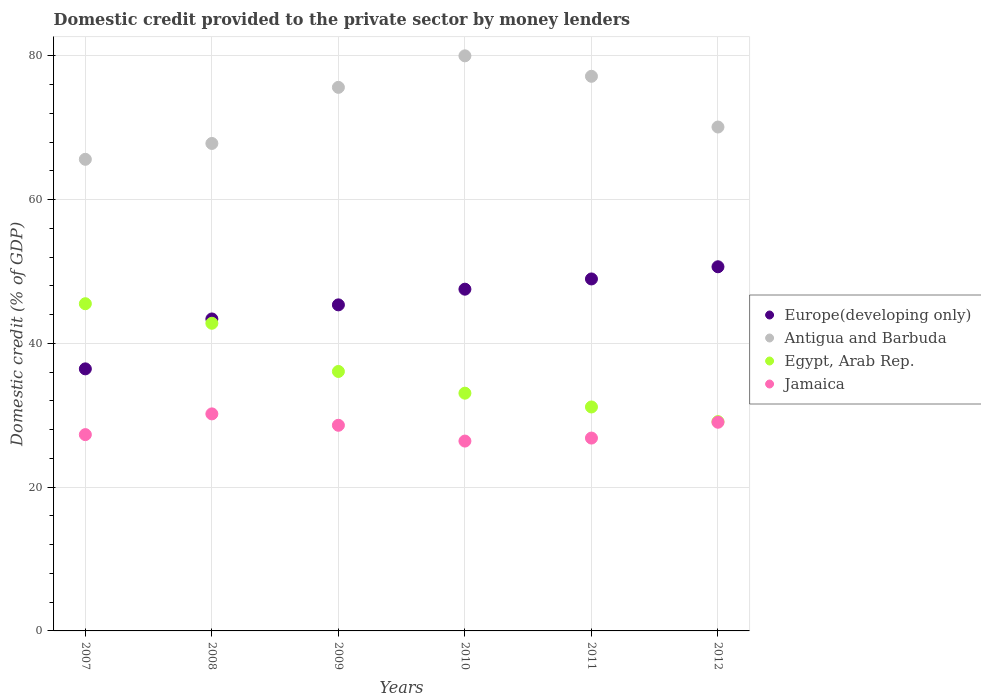How many different coloured dotlines are there?
Your answer should be very brief. 4. What is the domestic credit provided to the private sector by money lenders in Antigua and Barbuda in 2010?
Keep it short and to the point. 80. Across all years, what is the maximum domestic credit provided to the private sector by money lenders in Antigua and Barbuda?
Your response must be concise. 80. Across all years, what is the minimum domestic credit provided to the private sector by money lenders in Egypt, Arab Rep.?
Your answer should be very brief. 29.11. In which year was the domestic credit provided to the private sector by money lenders in Egypt, Arab Rep. minimum?
Your answer should be very brief. 2012. What is the total domestic credit provided to the private sector by money lenders in Europe(developing only) in the graph?
Your answer should be very brief. 272.36. What is the difference between the domestic credit provided to the private sector by money lenders in Europe(developing only) in 2009 and that in 2010?
Make the answer very short. -2.18. What is the difference between the domestic credit provided to the private sector by money lenders in Jamaica in 2012 and the domestic credit provided to the private sector by money lenders in Egypt, Arab Rep. in 2008?
Your answer should be very brief. -13.77. What is the average domestic credit provided to the private sector by money lenders in Egypt, Arab Rep. per year?
Provide a short and direct response. 36.29. In the year 2009, what is the difference between the domestic credit provided to the private sector by money lenders in Jamaica and domestic credit provided to the private sector by money lenders in Antigua and Barbuda?
Give a very brief answer. -47.01. In how many years, is the domestic credit provided to the private sector by money lenders in Antigua and Barbuda greater than 52 %?
Your answer should be very brief. 6. What is the ratio of the domestic credit provided to the private sector by money lenders in Europe(developing only) in 2009 to that in 2011?
Provide a short and direct response. 0.93. What is the difference between the highest and the second highest domestic credit provided to the private sector by money lenders in Europe(developing only)?
Your answer should be compact. 1.69. What is the difference between the highest and the lowest domestic credit provided to the private sector by money lenders in Egypt, Arab Rep.?
Keep it short and to the point. 16.4. Is the sum of the domestic credit provided to the private sector by money lenders in Europe(developing only) in 2010 and 2012 greater than the maximum domestic credit provided to the private sector by money lenders in Jamaica across all years?
Make the answer very short. Yes. Is it the case that in every year, the sum of the domestic credit provided to the private sector by money lenders in Jamaica and domestic credit provided to the private sector by money lenders in Egypt, Arab Rep.  is greater than the sum of domestic credit provided to the private sector by money lenders in Antigua and Barbuda and domestic credit provided to the private sector by money lenders in Europe(developing only)?
Give a very brief answer. No. Is it the case that in every year, the sum of the domestic credit provided to the private sector by money lenders in Europe(developing only) and domestic credit provided to the private sector by money lenders in Jamaica  is greater than the domestic credit provided to the private sector by money lenders in Egypt, Arab Rep.?
Provide a succinct answer. Yes. How many dotlines are there?
Provide a short and direct response. 4. Are the values on the major ticks of Y-axis written in scientific E-notation?
Provide a short and direct response. No. Does the graph contain grids?
Ensure brevity in your answer.  Yes. Where does the legend appear in the graph?
Provide a succinct answer. Center right. How are the legend labels stacked?
Your answer should be very brief. Vertical. What is the title of the graph?
Your response must be concise. Domestic credit provided to the private sector by money lenders. Does "Euro area" appear as one of the legend labels in the graph?
Offer a terse response. No. What is the label or title of the X-axis?
Give a very brief answer. Years. What is the label or title of the Y-axis?
Provide a short and direct response. Domestic credit (% of GDP). What is the Domestic credit (% of GDP) in Europe(developing only) in 2007?
Offer a terse response. 36.45. What is the Domestic credit (% of GDP) in Antigua and Barbuda in 2007?
Offer a very short reply. 65.61. What is the Domestic credit (% of GDP) in Egypt, Arab Rep. in 2007?
Offer a terse response. 45.52. What is the Domestic credit (% of GDP) of Jamaica in 2007?
Your response must be concise. 27.31. What is the Domestic credit (% of GDP) of Europe(developing only) in 2008?
Provide a succinct answer. 43.4. What is the Domestic credit (% of GDP) in Antigua and Barbuda in 2008?
Make the answer very short. 67.81. What is the Domestic credit (% of GDP) in Egypt, Arab Rep. in 2008?
Keep it short and to the point. 42.8. What is the Domestic credit (% of GDP) of Jamaica in 2008?
Keep it short and to the point. 30.19. What is the Domestic credit (% of GDP) in Europe(developing only) in 2009?
Offer a terse response. 45.36. What is the Domestic credit (% of GDP) in Antigua and Barbuda in 2009?
Make the answer very short. 75.61. What is the Domestic credit (% of GDP) in Egypt, Arab Rep. in 2009?
Your response must be concise. 36.09. What is the Domestic credit (% of GDP) of Jamaica in 2009?
Offer a very short reply. 28.61. What is the Domestic credit (% of GDP) in Europe(developing only) in 2010?
Your response must be concise. 47.54. What is the Domestic credit (% of GDP) in Antigua and Barbuda in 2010?
Offer a terse response. 80. What is the Domestic credit (% of GDP) of Egypt, Arab Rep. in 2010?
Offer a very short reply. 33.07. What is the Domestic credit (% of GDP) of Jamaica in 2010?
Provide a short and direct response. 26.41. What is the Domestic credit (% of GDP) in Europe(developing only) in 2011?
Give a very brief answer. 48.96. What is the Domestic credit (% of GDP) in Antigua and Barbuda in 2011?
Provide a short and direct response. 77.15. What is the Domestic credit (% of GDP) of Egypt, Arab Rep. in 2011?
Provide a succinct answer. 31.15. What is the Domestic credit (% of GDP) of Jamaica in 2011?
Keep it short and to the point. 26.83. What is the Domestic credit (% of GDP) in Europe(developing only) in 2012?
Offer a very short reply. 50.66. What is the Domestic credit (% of GDP) in Antigua and Barbuda in 2012?
Provide a short and direct response. 70.1. What is the Domestic credit (% of GDP) of Egypt, Arab Rep. in 2012?
Provide a short and direct response. 29.11. What is the Domestic credit (% of GDP) of Jamaica in 2012?
Give a very brief answer. 29.03. Across all years, what is the maximum Domestic credit (% of GDP) in Europe(developing only)?
Your response must be concise. 50.66. Across all years, what is the maximum Domestic credit (% of GDP) of Antigua and Barbuda?
Your answer should be very brief. 80. Across all years, what is the maximum Domestic credit (% of GDP) in Egypt, Arab Rep.?
Your response must be concise. 45.52. Across all years, what is the maximum Domestic credit (% of GDP) in Jamaica?
Your answer should be compact. 30.19. Across all years, what is the minimum Domestic credit (% of GDP) of Europe(developing only)?
Make the answer very short. 36.45. Across all years, what is the minimum Domestic credit (% of GDP) in Antigua and Barbuda?
Your answer should be very brief. 65.61. Across all years, what is the minimum Domestic credit (% of GDP) in Egypt, Arab Rep.?
Your response must be concise. 29.11. Across all years, what is the minimum Domestic credit (% of GDP) of Jamaica?
Your answer should be very brief. 26.41. What is the total Domestic credit (% of GDP) in Europe(developing only) in the graph?
Offer a very short reply. 272.36. What is the total Domestic credit (% of GDP) of Antigua and Barbuda in the graph?
Your answer should be compact. 436.28. What is the total Domestic credit (% of GDP) in Egypt, Arab Rep. in the graph?
Ensure brevity in your answer.  217.75. What is the total Domestic credit (% of GDP) of Jamaica in the graph?
Give a very brief answer. 168.37. What is the difference between the Domestic credit (% of GDP) in Europe(developing only) in 2007 and that in 2008?
Your answer should be very brief. -6.94. What is the difference between the Domestic credit (% of GDP) in Antigua and Barbuda in 2007 and that in 2008?
Offer a terse response. -2.2. What is the difference between the Domestic credit (% of GDP) of Egypt, Arab Rep. in 2007 and that in 2008?
Offer a very short reply. 2.72. What is the difference between the Domestic credit (% of GDP) in Jamaica in 2007 and that in 2008?
Offer a terse response. -2.88. What is the difference between the Domestic credit (% of GDP) in Europe(developing only) in 2007 and that in 2009?
Make the answer very short. -8.9. What is the difference between the Domestic credit (% of GDP) of Antigua and Barbuda in 2007 and that in 2009?
Give a very brief answer. -10.01. What is the difference between the Domestic credit (% of GDP) of Egypt, Arab Rep. in 2007 and that in 2009?
Your answer should be compact. 9.42. What is the difference between the Domestic credit (% of GDP) of Europe(developing only) in 2007 and that in 2010?
Offer a terse response. -11.08. What is the difference between the Domestic credit (% of GDP) of Antigua and Barbuda in 2007 and that in 2010?
Give a very brief answer. -14.39. What is the difference between the Domestic credit (% of GDP) of Egypt, Arab Rep. in 2007 and that in 2010?
Make the answer very short. 12.44. What is the difference between the Domestic credit (% of GDP) of Jamaica in 2007 and that in 2010?
Your response must be concise. 0.9. What is the difference between the Domestic credit (% of GDP) in Europe(developing only) in 2007 and that in 2011?
Give a very brief answer. -12.51. What is the difference between the Domestic credit (% of GDP) in Antigua and Barbuda in 2007 and that in 2011?
Offer a very short reply. -11.55. What is the difference between the Domestic credit (% of GDP) of Egypt, Arab Rep. in 2007 and that in 2011?
Make the answer very short. 14.36. What is the difference between the Domestic credit (% of GDP) in Jamaica in 2007 and that in 2011?
Ensure brevity in your answer.  0.48. What is the difference between the Domestic credit (% of GDP) in Europe(developing only) in 2007 and that in 2012?
Your answer should be compact. -14.2. What is the difference between the Domestic credit (% of GDP) in Antigua and Barbuda in 2007 and that in 2012?
Offer a very short reply. -4.49. What is the difference between the Domestic credit (% of GDP) in Egypt, Arab Rep. in 2007 and that in 2012?
Ensure brevity in your answer.  16.4. What is the difference between the Domestic credit (% of GDP) in Jamaica in 2007 and that in 2012?
Provide a succinct answer. -1.72. What is the difference between the Domestic credit (% of GDP) in Europe(developing only) in 2008 and that in 2009?
Provide a succinct answer. -1.96. What is the difference between the Domestic credit (% of GDP) in Antigua and Barbuda in 2008 and that in 2009?
Your answer should be compact. -7.8. What is the difference between the Domestic credit (% of GDP) of Egypt, Arab Rep. in 2008 and that in 2009?
Your response must be concise. 6.7. What is the difference between the Domestic credit (% of GDP) in Jamaica in 2008 and that in 2009?
Your answer should be very brief. 1.58. What is the difference between the Domestic credit (% of GDP) in Europe(developing only) in 2008 and that in 2010?
Ensure brevity in your answer.  -4.14. What is the difference between the Domestic credit (% of GDP) in Antigua and Barbuda in 2008 and that in 2010?
Offer a terse response. -12.19. What is the difference between the Domestic credit (% of GDP) in Egypt, Arab Rep. in 2008 and that in 2010?
Your answer should be very brief. 9.73. What is the difference between the Domestic credit (% of GDP) in Jamaica in 2008 and that in 2010?
Your response must be concise. 3.78. What is the difference between the Domestic credit (% of GDP) in Europe(developing only) in 2008 and that in 2011?
Provide a short and direct response. -5.57. What is the difference between the Domestic credit (% of GDP) in Antigua and Barbuda in 2008 and that in 2011?
Make the answer very short. -9.34. What is the difference between the Domestic credit (% of GDP) in Egypt, Arab Rep. in 2008 and that in 2011?
Make the answer very short. 11.64. What is the difference between the Domestic credit (% of GDP) in Jamaica in 2008 and that in 2011?
Give a very brief answer. 3.36. What is the difference between the Domestic credit (% of GDP) of Europe(developing only) in 2008 and that in 2012?
Ensure brevity in your answer.  -7.26. What is the difference between the Domestic credit (% of GDP) in Antigua and Barbuda in 2008 and that in 2012?
Make the answer very short. -2.29. What is the difference between the Domestic credit (% of GDP) in Egypt, Arab Rep. in 2008 and that in 2012?
Offer a very short reply. 13.68. What is the difference between the Domestic credit (% of GDP) in Jamaica in 2008 and that in 2012?
Provide a succinct answer. 1.16. What is the difference between the Domestic credit (% of GDP) in Europe(developing only) in 2009 and that in 2010?
Offer a terse response. -2.18. What is the difference between the Domestic credit (% of GDP) in Antigua and Barbuda in 2009 and that in 2010?
Offer a very short reply. -4.38. What is the difference between the Domestic credit (% of GDP) in Egypt, Arab Rep. in 2009 and that in 2010?
Provide a succinct answer. 3.02. What is the difference between the Domestic credit (% of GDP) of Jamaica in 2009 and that in 2010?
Offer a terse response. 2.2. What is the difference between the Domestic credit (% of GDP) in Europe(developing only) in 2009 and that in 2011?
Offer a terse response. -3.6. What is the difference between the Domestic credit (% of GDP) in Antigua and Barbuda in 2009 and that in 2011?
Your answer should be compact. -1.54. What is the difference between the Domestic credit (% of GDP) of Egypt, Arab Rep. in 2009 and that in 2011?
Give a very brief answer. 4.94. What is the difference between the Domestic credit (% of GDP) in Jamaica in 2009 and that in 2011?
Give a very brief answer. 1.78. What is the difference between the Domestic credit (% of GDP) of Europe(developing only) in 2009 and that in 2012?
Your answer should be compact. -5.3. What is the difference between the Domestic credit (% of GDP) of Antigua and Barbuda in 2009 and that in 2012?
Make the answer very short. 5.52. What is the difference between the Domestic credit (% of GDP) of Egypt, Arab Rep. in 2009 and that in 2012?
Provide a succinct answer. 6.98. What is the difference between the Domestic credit (% of GDP) of Jamaica in 2009 and that in 2012?
Ensure brevity in your answer.  -0.42. What is the difference between the Domestic credit (% of GDP) in Europe(developing only) in 2010 and that in 2011?
Your answer should be compact. -1.42. What is the difference between the Domestic credit (% of GDP) in Antigua and Barbuda in 2010 and that in 2011?
Ensure brevity in your answer.  2.85. What is the difference between the Domestic credit (% of GDP) in Egypt, Arab Rep. in 2010 and that in 2011?
Your answer should be compact. 1.92. What is the difference between the Domestic credit (% of GDP) in Jamaica in 2010 and that in 2011?
Your answer should be compact. -0.42. What is the difference between the Domestic credit (% of GDP) in Europe(developing only) in 2010 and that in 2012?
Give a very brief answer. -3.12. What is the difference between the Domestic credit (% of GDP) in Antigua and Barbuda in 2010 and that in 2012?
Make the answer very short. 9.9. What is the difference between the Domestic credit (% of GDP) in Egypt, Arab Rep. in 2010 and that in 2012?
Ensure brevity in your answer.  3.96. What is the difference between the Domestic credit (% of GDP) in Jamaica in 2010 and that in 2012?
Offer a terse response. -2.62. What is the difference between the Domestic credit (% of GDP) in Europe(developing only) in 2011 and that in 2012?
Provide a succinct answer. -1.69. What is the difference between the Domestic credit (% of GDP) in Antigua and Barbuda in 2011 and that in 2012?
Keep it short and to the point. 7.05. What is the difference between the Domestic credit (% of GDP) of Egypt, Arab Rep. in 2011 and that in 2012?
Your answer should be very brief. 2.04. What is the difference between the Domestic credit (% of GDP) of Jamaica in 2011 and that in 2012?
Your answer should be very brief. -2.2. What is the difference between the Domestic credit (% of GDP) of Europe(developing only) in 2007 and the Domestic credit (% of GDP) of Antigua and Barbuda in 2008?
Keep it short and to the point. -31.36. What is the difference between the Domestic credit (% of GDP) of Europe(developing only) in 2007 and the Domestic credit (% of GDP) of Egypt, Arab Rep. in 2008?
Provide a succinct answer. -6.34. What is the difference between the Domestic credit (% of GDP) in Europe(developing only) in 2007 and the Domestic credit (% of GDP) in Jamaica in 2008?
Your answer should be very brief. 6.26. What is the difference between the Domestic credit (% of GDP) of Antigua and Barbuda in 2007 and the Domestic credit (% of GDP) of Egypt, Arab Rep. in 2008?
Provide a succinct answer. 22.81. What is the difference between the Domestic credit (% of GDP) in Antigua and Barbuda in 2007 and the Domestic credit (% of GDP) in Jamaica in 2008?
Make the answer very short. 35.41. What is the difference between the Domestic credit (% of GDP) in Egypt, Arab Rep. in 2007 and the Domestic credit (% of GDP) in Jamaica in 2008?
Your answer should be compact. 15.32. What is the difference between the Domestic credit (% of GDP) of Europe(developing only) in 2007 and the Domestic credit (% of GDP) of Antigua and Barbuda in 2009?
Provide a short and direct response. -39.16. What is the difference between the Domestic credit (% of GDP) of Europe(developing only) in 2007 and the Domestic credit (% of GDP) of Egypt, Arab Rep. in 2009?
Provide a short and direct response. 0.36. What is the difference between the Domestic credit (% of GDP) of Europe(developing only) in 2007 and the Domestic credit (% of GDP) of Jamaica in 2009?
Provide a short and direct response. 7.85. What is the difference between the Domestic credit (% of GDP) of Antigua and Barbuda in 2007 and the Domestic credit (% of GDP) of Egypt, Arab Rep. in 2009?
Give a very brief answer. 29.51. What is the difference between the Domestic credit (% of GDP) of Antigua and Barbuda in 2007 and the Domestic credit (% of GDP) of Jamaica in 2009?
Your answer should be very brief. 37. What is the difference between the Domestic credit (% of GDP) in Egypt, Arab Rep. in 2007 and the Domestic credit (% of GDP) in Jamaica in 2009?
Your answer should be very brief. 16.91. What is the difference between the Domestic credit (% of GDP) in Europe(developing only) in 2007 and the Domestic credit (% of GDP) in Antigua and Barbuda in 2010?
Provide a short and direct response. -43.54. What is the difference between the Domestic credit (% of GDP) in Europe(developing only) in 2007 and the Domestic credit (% of GDP) in Egypt, Arab Rep. in 2010?
Provide a succinct answer. 3.38. What is the difference between the Domestic credit (% of GDP) of Europe(developing only) in 2007 and the Domestic credit (% of GDP) of Jamaica in 2010?
Provide a succinct answer. 10.04. What is the difference between the Domestic credit (% of GDP) of Antigua and Barbuda in 2007 and the Domestic credit (% of GDP) of Egypt, Arab Rep. in 2010?
Ensure brevity in your answer.  32.53. What is the difference between the Domestic credit (% of GDP) in Antigua and Barbuda in 2007 and the Domestic credit (% of GDP) in Jamaica in 2010?
Give a very brief answer. 39.2. What is the difference between the Domestic credit (% of GDP) in Egypt, Arab Rep. in 2007 and the Domestic credit (% of GDP) in Jamaica in 2010?
Your response must be concise. 19.11. What is the difference between the Domestic credit (% of GDP) of Europe(developing only) in 2007 and the Domestic credit (% of GDP) of Antigua and Barbuda in 2011?
Offer a terse response. -40.7. What is the difference between the Domestic credit (% of GDP) in Europe(developing only) in 2007 and the Domestic credit (% of GDP) in Egypt, Arab Rep. in 2011?
Provide a succinct answer. 5.3. What is the difference between the Domestic credit (% of GDP) of Europe(developing only) in 2007 and the Domestic credit (% of GDP) of Jamaica in 2011?
Your answer should be compact. 9.63. What is the difference between the Domestic credit (% of GDP) in Antigua and Barbuda in 2007 and the Domestic credit (% of GDP) in Egypt, Arab Rep. in 2011?
Provide a short and direct response. 34.45. What is the difference between the Domestic credit (% of GDP) in Antigua and Barbuda in 2007 and the Domestic credit (% of GDP) in Jamaica in 2011?
Make the answer very short. 38.78. What is the difference between the Domestic credit (% of GDP) of Egypt, Arab Rep. in 2007 and the Domestic credit (% of GDP) of Jamaica in 2011?
Your answer should be very brief. 18.69. What is the difference between the Domestic credit (% of GDP) of Europe(developing only) in 2007 and the Domestic credit (% of GDP) of Antigua and Barbuda in 2012?
Offer a very short reply. -33.64. What is the difference between the Domestic credit (% of GDP) of Europe(developing only) in 2007 and the Domestic credit (% of GDP) of Egypt, Arab Rep. in 2012?
Your answer should be very brief. 7.34. What is the difference between the Domestic credit (% of GDP) of Europe(developing only) in 2007 and the Domestic credit (% of GDP) of Jamaica in 2012?
Offer a very short reply. 7.43. What is the difference between the Domestic credit (% of GDP) of Antigua and Barbuda in 2007 and the Domestic credit (% of GDP) of Egypt, Arab Rep. in 2012?
Offer a very short reply. 36.49. What is the difference between the Domestic credit (% of GDP) of Antigua and Barbuda in 2007 and the Domestic credit (% of GDP) of Jamaica in 2012?
Your answer should be compact. 36.58. What is the difference between the Domestic credit (% of GDP) in Egypt, Arab Rep. in 2007 and the Domestic credit (% of GDP) in Jamaica in 2012?
Your answer should be compact. 16.49. What is the difference between the Domestic credit (% of GDP) of Europe(developing only) in 2008 and the Domestic credit (% of GDP) of Antigua and Barbuda in 2009?
Give a very brief answer. -32.22. What is the difference between the Domestic credit (% of GDP) in Europe(developing only) in 2008 and the Domestic credit (% of GDP) in Egypt, Arab Rep. in 2009?
Provide a succinct answer. 7.3. What is the difference between the Domestic credit (% of GDP) in Europe(developing only) in 2008 and the Domestic credit (% of GDP) in Jamaica in 2009?
Give a very brief answer. 14.79. What is the difference between the Domestic credit (% of GDP) of Antigua and Barbuda in 2008 and the Domestic credit (% of GDP) of Egypt, Arab Rep. in 2009?
Ensure brevity in your answer.  31.72. What is the difference between the Domestic credit (% of GDP) in Antigua and Barbuda in 2008 and the Domestic credit (% of GDP) in Jamaica in 2009?
Provide a short and direct response. 39.2. What is the difference between the Domestic credit (% of GDP) of Egypt, Arab Rep. in 2008 and the Domestic credit (% of GDP) of Jamaica in 2009?
Provide a succinct answer. 14.19. What is the difference between the Domestic credit (% of GDP) of Europe(developing only) in 2008 and the Domestic credit (% of GDP) of Antigua and Barbuda in 2010?
Give a very brief answer. -36.6. What is the difference between the Domestic credit (% of GDP) of Europe(developing only) in 2008 and the Domestic credit (% of GDP) of Egypt, Arab Rep. in 2010?
Your response must be concise. 10.32. What is the difference between the Domestic credit (% of GDP) in Europe(developing only) in 2008 and the Domestic credit (% of GDP) in Jamaica in 2010?
Your response must be concise. 16.99. What is the difference between the Domestic credit (% of GDP) in Antigua and Barbuda in 2008 and the Domestic credit (% of GDP) in Egypt, Arab Rep. in 2010?
Ensure brevity in your answer.  34.74. What is the difference between the Domestic credit (% of GDP) in Antigua and Barbuda in 2008 and the Domestic credit (% of GDP) in Jamaica in 2010?
Offer a terse response. 41.4. What is the difference between the Domestic credit (% of GDP) of Egypt, Arab Rep. in 2008 and the Domestic credit (% of GDP) of Jamaica in 2010?
Your answer should be compact. 16.39. What is the difference between the Domestic credit (% of GDP) of Europe(developing only) in 2008 and the Domestic credit (% of GDP) of Antigua and Barbuda in 2011?
Make the answer very short. -33.76. What is the difference between the Domestic credit (% of GDP) of Europe(developing only) in 2008 and the Domestic credit (% of GDP) of Egypt, Arab Rep. in 2011?
Make the answer very short. 12.24. What is the difference between the Domestic credit (% of GDP) of Europe(developing only) in 2008 and the Domestic credit (% of GDP) of Jamaica in 2011?
Ensure brevity in your answer.  16.57. What is the difference between the Domestic credit (% of GDP) in Antigua and Barbuda in 2008 and the Domestic credit (% of GDP) in Egypt, Arab Rep. in 2011?
Make the answer very short. 36.66. What is the difference between the Domestic credit (% of GDP) in Antigua and Barbuda in 2008 and the Domestic credit (% of GDP) in Jamaica in 2011?
Your answer should be very brief. 40.98. What is the difference between the Domestic credit (% of GDP) in Egypt, Arab Rep. in 2008 and the Domestic credit (% of GDP) in Jamaica in 2011?
Offer a terse response. 15.97. What is the difference between the Domestic credit (% of GDP) in Europe(developing only) in 2008 and the Domestic credit (% of GDP) in Antigua and Barbuda in 2012?
Give a very brief answer. -26.7. What is the difference between the Domestic credit (% of GDP) in Europe(developing only) in 2008 and the Domestic credit (% of GDP) in Egypt, Arab Rep. in 2012?
Your response must be concise. 14.28. What is the difference between the Domestic credit (% of GDP) of Europe(developing only) in 2008 and the Domestic credit (% of GDP) of Jamaica in 2012?
Your response must be concise. 14.37. What is the difference between the Domestic credit (% of GDP) in Antigua and Barbuda in 2008 and the Domestic credit (% of GDP) in Egypt, Arab Rep. in 2012?
Ensure brevity in your answer.  38.7. What is the difference between the Domestic credit (% of GDP) of Antigua and Barbuda in 2008 and the Domestic credit (% of GDP) of Jamaica in 2012?
Your answer should be very brief. 38.78. What is the difference between the Domestic credit (% of GDP) in Egypt, Arab Rep. in 2008 and the Domestic credit (% of GDP) in Jamaica in 2012?
Provide a succinct answer. 13.77. What is the difference between the Domestic credit (% of GDP) of Europe(developing only) in 2009 and the Domestic credit (% of GDP) of Antigua and Barbuda in 2010?
Your answer should be very brief. -34.64. What is the difference between the Domestic credit (% of GDP) in Europe(developing only) in 2009 and the Domestic credit (% of GDP) in Egypt, Arab Rep. in 2010?
Provide a succinct answer. 12.29. What is the difference between the Domestic credit (% of GDP) in Europe(developing only) in 2009 and the Domestic credit (% of GDP) in Jamaica in 2010?
Keep it short and to the point. 18.95. What is the difference between the Domestic credit (% of GDP) in Antigua and Barbuda in 2009 and the Domestic credit (% of GDP) in Egypt, Arab Rep. in 2010?
Ensure brevity in your answer.  42.54. What is the difference between the Domestic credit (% of GDP) in Antigua and Barbuda in 2009 and the Domestic credit (% of GDP) in Jamaica in 2010?
Keep it short and to the point. 49.2. What is the difference between the Domestic credit (% of GDP) of Egypt, Arab Rep. in 2009 and the Domestic credit (% of GDP) of Jamaica in 2010?
Provide a short and direct response. 9.68. What is the difference between the Domestic credit (% of GDP) of Europe(developing only) in 2009 and the Domestic credit (% of GDP) of Antigua and Barbuda in 2011?
Make the answer very short. -31.79. What is the difference between the Domestic credit (% of GDP) in Europe(developing only) in 2009 and the Domestic credit (% of GDP) in Egypt, Arab Rep. in 2011?
Make the answer very short. 14.2. What is the difference between the Domestic credit (% of GDP) of Europe(developing only) in 2009 and the Domestic credit (% of GDP) of Jamaica in 2011?
Your answer should be very brief. 18.53. What is the difference between the Domestic credit (% of GDP) in Antigua and Barbuda in 2009 and the Domestic credit (% of GDP) in Egypt, Arab Rep. in 2011?
Keep it short and to the point. 44.46. What is the difference between the Domestic credit (% of GDP) in Antigua and Barbuda in 2009 and the Domestic credit (% of GDP) in Jamaica in 2011?
Offer a terse response. 48.79. What is the difference between the Domestic credit (% of GDP) in Egypt, Arab Rep. in 2009 and the Domestic credit (% of GDP) in Jamaica in 2011?
Your answer should be compact. 9.27. What is the difference between the Domestic credit (% of GDP) of Europe(developing only) in 2009 and the Domestic credit (% of GDP) of Antigua and Barbuda in 2012?
Give a very brief answer. -24.74. What is the difference between the Domestic credit (% of GDP) in Europe(developing only) in 2009 and the Domestic credit (% of GDP) in Egypt, Arab Rep. in 2012?
Give a very brief answer. 16.24. What is the difference between the Domestic credit (% of GDP) in Europe(developing only) in 2009 and the Domestic credit (% of GDP) in Jamaica in 2012?
Your response must be concise. 16.33. What is the difference between the Domestic credit (% of GDP) in Antigua and Barbuda in 2009 and the Domestic credit (% of GDP) in Egypt, Arab Rep. in 2012?
Ensure brevity in your answer.  46.5. What is the difference between the Domestic credit (% of GDP) of Antigua and Barbuda in 2009 and the Domestic credit (% of GDP) of Jamaica in 2012?
Offer a terse response. 46.59. What is the difference between the Domestic credit (% of GDP) of Egypt, Arab Rep. in 2009 and the Domestic credit (% of GDP) of Jamaica in 2012?
Make the answer very short. 7.06. What is the difference between the Domestic credit (% of GDP) in Europe(developing only) in 2010 and the Domestic credit (% of GDP) in Antigua and Barbuda in 2011?
Offer a very short reply. -29.61. What is the difference between the Domestic credit (% of GDP) in Europe(developing only) in 2010 and the Domestic credit (% of GDP) in Egypt, Arab Rep. in 2011?
Your response must be concise. 16.38. What is the difference between the Domestic credit (% of GDP) in Europe(developing only) in 2010 and the Domestic credit (% of GDP) in Jamaica in 2011?
Provide a succinct answer. 20.71. What is the difference between the Domestic credit (% of GDP) in Antigua and Barbuda in 2010 and the Domestic credit (% of GDP) in Egypt, Arab Rep. in 2011?
Give a very brief answer. 48.84. What is the difference between the Domestic credit (% of GDP) in Antigua and Barbuda in 2010 and the Domestic credit (% of GDP) in Jamaica in 2011?
Keep it short and to the point. 53.17. What is the difference between the Domestic credit (% of GDP) in Egypt, Arab Rep. in 2010 and the Domestic credit (% of GDP) in Jamaica in 2011?
Your answer should be compact. 6.25. What is the difference between the Domestic credit (% of GDP) in Europe(developing only) in 2010 and the Domestic credit (% of GDP) in Antigua and Barbuda in 2012?
Offer a very short reply. -22.56. What is the difference between the Domestic credit (% of GDP) of Europe(developing only) in 2010 and the Domestic credit (% of GDP) of Egypt, Arab Rep. in 2012?
Give a very brief answer. 18.43. What is the difference between the Domestic credit (% of GDP) in Europe(developing only) in 2010 and the Domestic credit (% of GDP) in Jamaica in 2012?
Give a very brief answer. 18.51. What is the difference between the Domestic credit (% of GDP) in Antigua and Barbuda in 2010 and the Domestic credit (% of GDP) in Egypt, Arab Rep. in 2012?
Make the answer very short. 50.89. What is the difference between the Domestic credit (% of GDP) of Antigua and Barbuda in 2010 and the Domestic credit (% of GDP) of Jamaica in 2012?
Offer a very short reply. 50.97. What is the difference between the Domestic credit (% of GDP) of Egypt, Arab Rep. in 2010 and the Domestic credit (% of GDP) of Jamaica in 2012?
Offer a terse response. 4.04. What is the difference between the Domestic credit (% of GDP) in Europe(developing only) in 2011 and the Domestic credit (% of GDP) in Antigua and Barbuda in 2012?
Give a very brief answer. -21.14. What is the difference between the Domestic credit (% of GDP) of Europe(developing only) in 2011 and the Domestic credit (% of GDP) of Egypt, Arab Rep. in 2012?
Provide a short and direct response. 19.85. What is the difference between the Domestic credit (% of GDP) of Europe(developing only) in 2011 and the Domestic credit (% of GDP) of Jamaica in 2012?
Ensure brevity in your answer.  19.93. What is the difference between the Domestic credit (% of GDP) in Antigua and Barbuda in 2011 and the Domestic credit (% of GDP) in Egypt, Arab Rep. in 2012?
Provide a short and direct response. 48.04. What is the difference between the Domestic credit (% of GDP) in Antigua and Barbuda in 2011 and the Domestic credit (% of GDP) in Jamaica in 2012?
Your response must be concise. 48.12. What is the difference between the Domestic credit (% of GDP) of Egypt, Arab Rep. in 2011 and the Domestic credit (% of GDP) of Jamaica in 2012?
Ensure brevity in your answer.  2.13. What is the average Domestic credit (% of GDP) in Europe(developing only) per year?
Offer a very short reply. 45.39. What is the average Domestic credit (% of GDP) of Antigua and Barbuda per year?
Give a very brief answer. 72.71. What is the average Domestic credit (% of GDP) of Egypt, Arab Rep. per year?
Keep it short and to the point. 36.29. What is the average Domestic credit (% of GDP) of Jamaica per year?
Make the answer very short. 28.06. In the year 2007, what is the difference between the Domestic credit (% of GDP) of Europe(developing only) and Domestic credit (% of GDP) of Antigua and Barbuda?
Your response must be concise. -29.15. In the year 2007, what is the difference between the Domestic credit (% of GDP) in Europe(developing only) and Domestic credit (% of GDP) in Egypt, Arab Rep.?
Make the answer very short. -9.06. In the year 2007, what is the difference between the Domestic credit (% of GDP) of Europe(developing only) and Domestic credit (% of GDP) of Jamaica?
Ensure brevity in your answer.  9.15. In the year 2007, what is the difference between the Domestic credit (% of GDP) of Antigua and Barbuda and Domestic credit (% of GDP) of Egypt, Arab Rep.?
Your answer should be compact. 20.09. In the year 2007, what is the difference between the Domestic credit (% of GDP) of Antigua and Barbuda and Domestic credit (% of GDP) of Jamaica?
Your answer should be very brief. 38.3. In the year 2007, what is the difference between the Domestic credit (% of GDP) in Egypt, Arab Rep. and Domestic credit (% of GDP) in Jamaica?
Your answer should be very brief. 18.21. In the year 2008, what is the difference between the Domestic credit (% of GDP) in Europe(developing only) and Domestic credit (% of GDP) in Antigua and Barbuda?
Provide a short and direct response. -24.41. In the year 2008, what is the difference between the Domestic credit (% of GDP) in Europe(developing only) and Domestic credit (% of GDP) in Egypt, Arab Rep.?
Give a very brief answer. 0.6. In the year 2008, what is the difference between the Domestic credit (% of GDP) in Europe(developing only) and Domestic credit (% of GDP) in Jamaica?
Give a very brief answer. 13.2. In the year 2008, what is the difference between the Domestic credit (% of GDP) in Antigua and Barbuda and Domestic credit (% of GDP) in Egypt, Arab Rep.?
Keep it short and to the point. 25.01. In the year 2008, what is the difference between the Domestic credit (% of GDP) of Antigua and Barbuda and Domestic credit (% of GDP) of Jamaica?
Offer a very short reply. 37.62. In the year 2008, what is the difference between the Domestic credit (% of GDP) in Egypt, Arab Rep. and Domestic credit (% of GDP) in Jamaica?
Give a very brief answer. 12.61. In the year 2009, what is the difference between the Domestic credit (% of GDP) of Europe(developing only) and Domestic credit (% of GDP) of Antigua and Barbuda?
Offer a very short reply. -30.26. In the year 2009, what is the difference between the Domestic credit (% of GDP) in Europe(developing only) and Domestic credit (% of GDP) in Egypt, Arab Rep.?
Provide a succinct answer. 9.26. In the year 2009, what is the difference between the Domestic credit (% of GDP) in Europe(developing only) and Domestic credit (% of GDP) in Jamaica?
Give a very brief answer. 16.75. In the year 2009, what is the difference between the Domestic credit (% of GDP) in Antigua and Barbuda and Domestic credit (% of GDP) in Egypt, Arab Rep.?
Offer a terse response. 39.52. In the year 2009, what is the difference between the Domestic credit (% of GDP) of Antigua and Barbuda and Domestic credit (% of GDP) of Jamaica?
Provide a short and direct response. 47.01. In the year 2009, what is the difference between the Domestic credit (% of GDP) in Egypt, Arab Rep. and Domestic credit (% of GDP) in Jamaica?
Make the answer very short. 7.49. In the year 2010, what is the difference between the Domestic credit (% of GDP) of Europe(developing only) and Domestic credit (% of GDP) of Antigua and Barbuda?
Offer a very short reply. -32.46. In the year 2010, what is the difference between the Domestic credit (% of GDP) in Europe(developing only) and Domestic credit (% of GDP) in Egypt, Arab Rep.?
Give a very brief answer. 14.47. In the year 2010, what is the difference between the Domestic credit (% of GDP) in Europe(developing only) and Domestic credit (% of GDP) in Jamaica?
Give a very brief answer. 21.13. In the year 2010, what is the difference between the Domestic credit (% of GDP) in Antigua and Barbuda and Domestic credit (% of GDP) in Egypt, Arab Rep.?
Your response must be concise. 46.93. In the year 2010, what is the difference between the Domestic credit (% of GDP) in Antigua and Barbuda and Domestic credit (% of GDP) in Jamaica?
Give a very brief answer. 53.59. In the year 2010, what is the difference between the Domestic credit (% of GDP) in Egypt, Arab Rep. and Domestic credit (% of GDP) in Jamaica?
Your response must be concise. 6.66. In the year 2011, what is the difference between the Domestic credit (% of GDP) of Europe(developing only) and Domestic credit (% of GDP) of Antigua and Barbuda?
Make the answer very short. -28.19. In the year 2011, what is the difference between the Domestic credit (% of GDP) of Europe(developing only) and Domestic credit (% of GDP) of Egypt, Arab Rep.?
Your response must be concise. 17.81. In the year 2011, what is the difference between the Domestic credit (% of GDP) in Europe(developing only) and Domestic credit (% of GDP) in Jamaica?
Keep it short and to the point. 22.14. In the year 2011, what is the difference between the Domestic credit (% of GDP) in Antigua and Barbuda and Domestic credit (% of GDP) in Egypt, Arab Rep.?
Keep it short and to the point. 46. In the year 2011, what is the difference between the Domestic credit (% of GDP) of Antigua and Barbuda and Domestic credit (% of GDP) of Jamaica?
Your answer should be very brief. 50.32. In the year 2011, what is the difference between the Domestic credit (% of GDP) of Egypt, Arab Rep. and Domestic credit (% of GDP) of Jamaica?
Your answer should be compact. 4.33. In the year 2012, what is the difference between the Domestic credit (% of GDP) of Europe(developing only) and Domestic credit (% of GDP) of Antigua and Barbuda?
Make the answer very short. -19.44. In the year 2012, what is the difference between the Domestic credit (% of GDP) in Europe(developing only) and Domestic credit (% of GDP) in Egypt, Arab Rep.?
Make the answer very short. 21.54. In the year 2012, what is the difference between the Domestic credit (% of GDP) of Europe(developing only) and Domestic credit (% of GDP) of Jamaica?
Keep it short and to the point. 21.63. In the year 2012, what is the difference between the Domestic credit (% of GDP) of Antigua and Barbuda and Domestic credit (% of GDP) of Egypt, Arab Rep.?
Provide a short and direct response. 40.98. In the year 2012, what is the difference between the Domestic credit (% of GDP) of Antigua and Barbuda and Domestic credit (% of GDP) of Jamaica?
Offer a terse response. 41.07. In the year 2012, what is the difference between the Domestic credit (% of GDP) of Egypt, Arab Rep. and Domestic credit (% of GDP) of Jamaica?
Provide a succinct answer. 0.08. What is the ratio of the Domestic credit (% of GDP) in Europe(developing only) in 2007 to that in 2008?
Ensure brevity in your answer.  0.84. What is the ratio of the Domestic credit (% of GDP) of Antigua and Barbuda in 2007 to that in 2008?
Offer a very short reply. 0.97. What is the ratio of the Domestic credit (% of GDP) in Egypt, Arab Rep. in 2007 to that in 2008?
Make the answer very short. 1.06. What is the ratio of the Domestic credit (% of GDP) in Jamaica in 2007 to that in 2008?
Make the answer very short. 0.9. What is the ratio of the Domestic credit (% of GDP) in Europe(developing only) in 2007 to that in 2009?
Your answer should be very brief. 0.8. What is the ratio of the Domestic credit (% of GDP) in Antigua and Barbuda in 2007 to that in 2009?
Provide a succinct answer. 0.87. What is the ratio of the Domestic credit (% of GDP) in Egypt, Arab Rep. in 2007 to that in 2009?
Offer a terse response. 1.26. What is the ratio of the Domestic credit (% of GDP) in Jamaica in 2007 to that in 2009?
Ensure brevity in your answer.  0.95. What is the ratio of the Domestic credit (% of GDP) of Europe(developing only) in 2007 to that in 2010?
Provide a succinct answer. 0.77. What is the ratio of the Domestic credit (% of GDP) in Antigua and Barbuda in 2007 to that in 2010?
Your answer should be very brief. 0.82. What is the ratio of the Domestic credit (% of GDP) of Egypt, Arab Rep. in 2007 to that in 2010?
Make the answer very short. 1.38. What is the ratio of the Domestic credit (% of GDP) of Jamaica in 2007 to that in 2010?
Offer a very short reply. 1.03. What is the ratio of the Domestic credit (% of GDP) of Europe(developing only) in 2007 to that in 2011?
Give a very brief answer. 0.74. What is the ratio of the Domestic credit (% of GDP) in Antigua and Barbuda in 2007 to that in 2011?
Offer a very short reply. 0.85. What is the ratio of the Domestic credit (% of GDP) of Egypt, Arab Rep. in 2007 to that in 2011?
Provide a short and direct response. 1.46. What is the ratio of the Domestic credit (% of GDP) of Jamaica in 2007 to that in 2011?
Your response must be concise. 1.02. What is the ratio of the Domestic credit (% of GDP) of Europe(developing only) in 2007 to that in 2012?
Give a very brief answer. 0.72. What is the ratio of the Domestic credit (% of GDP) of Antigua and Barbuda in 2007 to that in 2012?
Keep it short and to the point. 0.94. What is the ratio of the Domestic credit (% of GDP) in Egypt, Arab Rep. in 2007 to that in 2012?
Your answer should be very brief. 1.56. What is the ratio of the Domestic credit (% of GDP) in Jamaica in 2007 to that in 2012?
Provide a succinct answer. 0.94. What is the ratio of the Domestic credit (% of GDP) in Europe(developing only) in 2008 to that in 2009?
Provide a short and direct response. 0.96. What is the ratio of the Domestic credit (% of GDP) in Antigua and Barbuda in 2008 to that in 2009?
Provide a succinct answer. 0.9. What is the ratio of the Domestic credit (% of GDP) in Egypt, Arab Rep. in 2008 to that in 2009?
Make the answer very short. 1.19. What is the ratio of the Domestic credit (% of GDP) of Jamaica in 2008 to that in 2009?
Make the answer very short. 1.06. What is the ratio of the Domestic credit (% of GDP) in Europe(developing only) in 2008 to that in 2010?
Your answer should be compact. 0.91. What is the ratio of the Domestic credit (% of GDP) of Antigua and Barbuda in 2008 to that in 2010?
Provide a short and direct response. 0.85. What is the ratio of the Domestic credit (% of GDP) of Egypt, Arab Rep. in 2008 to that in 2010?
Provide a short and direct response. 1.29. What is the ratio of the Domestic credit (% of GDP) of Jamaica in 2008 to that in 2010?
Make the answer very short. 1.14. What is the ratio of the Domestic credit (% of GDP) in Europe(developing only) in 2008 to that in 2011?
Offer a very short reply. 0.89. What is the ratio of the Domestic credit (% of GDP) of Antigua and Barbuda in 2008 to that in 2011?
Provide a short and direct response. 0.88. What is the ratio of the Domestic credit (% of GDP) in Egypt, Arab Rep. in 2008 to that in 2011?
Give a very brief answer. 1.37. What is the ratio of the Domestic credit (% of GDP) of Jamaica in 2008 to that in 2011?
Your answer should be very brief. 1.13. What is the ratio of the Domestic credit (% of GDP) of Europe(developing only) in 2008 to that in 2012?
Your answer should be compact. 0.86. What is the ratio of the Domestic credit (% of GDP) in Antigua and Barbuda in 2008 to that in 2012?
Your response must be concise. 0.97. What is the ratio of the Domestic credit (% of GDP) in Egypt, Arab Rep. in 2008 to that in 2012?
Offer a very short reply. 1.47. What is the ratio of the Domestic credit (% of GDP) in Jamaica in 2008 to that in 2012?
Offer a very short reply. 1.04. What is the ratio of the Domestic credit (% of GDP) in Europe(developing only) in 2009 to that in 2010?
Your answer should be compact. 0.95. What is the ratio of the Domestic credit (% of GDP) in Antigua and Barbuda in 2009 to that in 2010?
Provide a short and direct response. 0.95. What is the ratio of the Domestic credit (% of GDP) of Egypt, Arab Rep. in 2009 to that in 2010?
Your response must be concise. 1.09. What is the ratio of the Domestic credit (% of GDP) of Jamaica in 2009 to that in 2010?
Offer a terse response. 1.08. What is the ratio of the Domestic credit (% of GDP) in Europe(developing only) in 2009 to that in 2011?
Offer a very short reply. 0.93. What is the ratio of the Domestic credit (% of GDP) in Antigua and Barbuda in 2009 to that in 2011?
Ensure brevity in your answer.  0.98. What is the ratio of the Domestic credit (% of GDP) in Egypt, Arab Rep. in 2009 to that in 2011?
Provide a short and direct response. 1.16. What is the ratio of the Domestic credit (% of GDP) of Jamaica in 2009 to that in 2011?
Keep it short and to the point. 1.07. What is the ratio of the Domestic credit (% of GDP) in Europe(developing only) in 2009 to that in 2012?
Make the answer very short. 0.9. What is the ratio of the Domestic credit (% of GDP) in Antigua and Barbuda in 2009 to that in 2012?
Offer a terse response. 1.08. What is the ratio of the Domestic credit (% of GDP) of Egypt, Arab Rep. in 2009 to that in 2012?
Make the answer very short. 1.24. What is the ratio of the Domestic credit (% of GDP) of Jamaica in 2009 to that in 2012?
Your answer should be very brief. 0.99. What is the ratio of the Domestic credit (% of GDP) in Europe(developing only) in 2010 to that in 2011?
Your response must be concise. 0.97. What is the ratio of the Domestic credit (% of GDP) in Antigua and Barbuda in 2010 to that in 2011?
Your answer should be compact. 1.04. What is the ratio of the Domestic credit (% of GDP) in Egypt, Arab Rep. in 2010 to that in 2011?
Ensure brevity in your answer.  1.06. What is the ratio of the Domestic credit (% of GDP) of Jamaica in 2010 to that in 2011?
Offer a terse response. 0.98. What is the ratio of the Domestic credit (% of GDP) in Europe(developing only) in 2010 to that in 2012?
Your answer should be very brief. 0.94. What is the ratio of the Domestic credit (% of GDP) in Antigua and Barbuda in 2010 to that in 2012?
Your answer should be very brief. 1.14. What is the ratio of the Domestic credit (% of GDP) in Egypt, Arab Rep. in 2010 to that in 2012?
Your response must be concise. 1.14. What is the ratio of the Domestic credit (% of GDP) of Jamaica in 2010 to that in 2012?
Your response must be concise. 0.91. What is the ratio of the Domestic credit (% of GDP) of Europe(developing only) in 2011 to that in 2012?
Provide a short and direct response. 0.97. What is the ratio of the Domestic credit (% of GDP) in Antigua and Barbuda in 2011 to that in 2012?
Keep it short and to the point. 1.1. What is the ratio of the Domestic credit (% of GDP) in Egypt, Arab Rep. in 2011 to that in 2012?
Keep it short and to the point. 1.07. What is the ratio of the Domestic credit (% of GDP) of Jamaica in 2011 to that in 2012?
Your answer should be compact. 0.92. What is the difference between the highest and the second highest Domestic credit (% of GDP) in Europe(developing only)?
Keep it short and to the point. 1.69. What is the difference between the highest and the second highest Domestic credit (% of GDP) of Antigua and Barbuda?
Provide a short and direct response. 2.85. What is the difference between the highest and the second highest Domestic credit (% of GDP) of Egypt, Arab Rep.?
Keep it short and to the point. 2.72. What is the difference between the highest and the second highest Domestic credit (% of GDP) of Jamaica?
Make the answer very short. 1.16. What is the difference between the highest and the lowest Domestic credit (% of GDP) in Europe(developing only)?
Give a very brief answer. 14.2. What is the difference between the highest and the lowest Domestic credit (% of GDP) of Antigua and Barbuda?
Provide a short and direct response. 14.39. What is the difference between the highest and the lowest Domestic credit (% of GDP) of Egypt, Arab Rep.?
Offer a very short reply. 16.4. What is the difference between the highest and the lowest Domestic credit (% of GDP) of Jamaica?
Offer a very short reply. 3.78. 